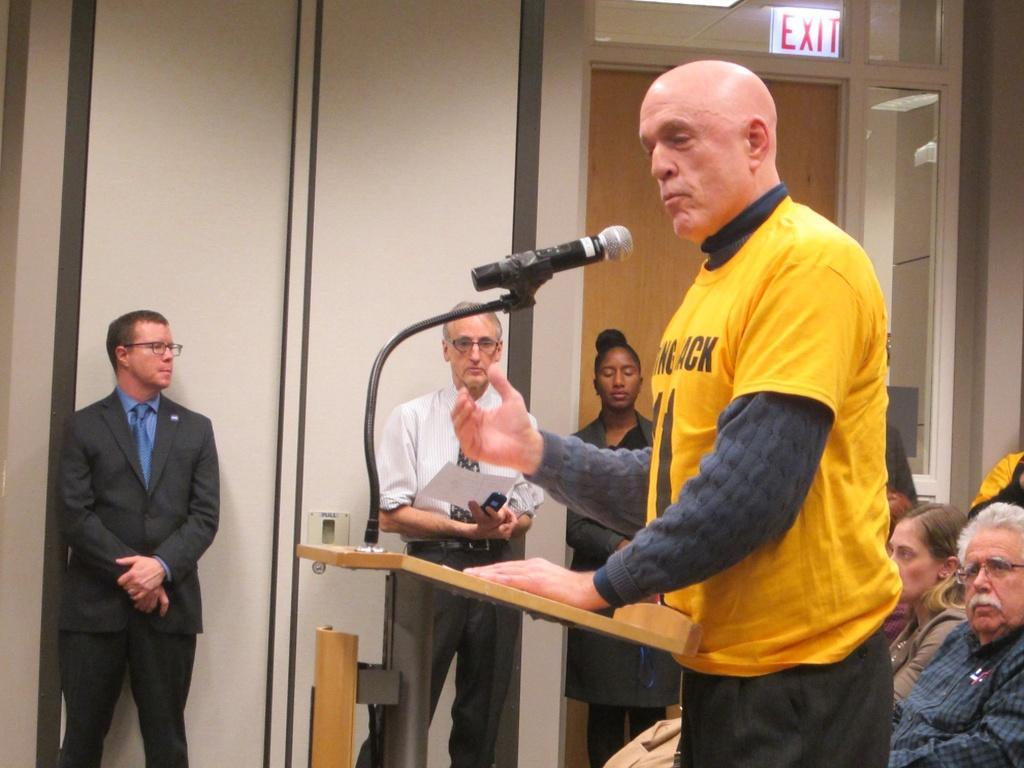How would you summarize this image in a sentence or two? In this image I can see few people sitting and few people standing. In front I can see a person standing and wearing yellow shirt. I can see a mic,stand and podium. Back I can see a wall. 